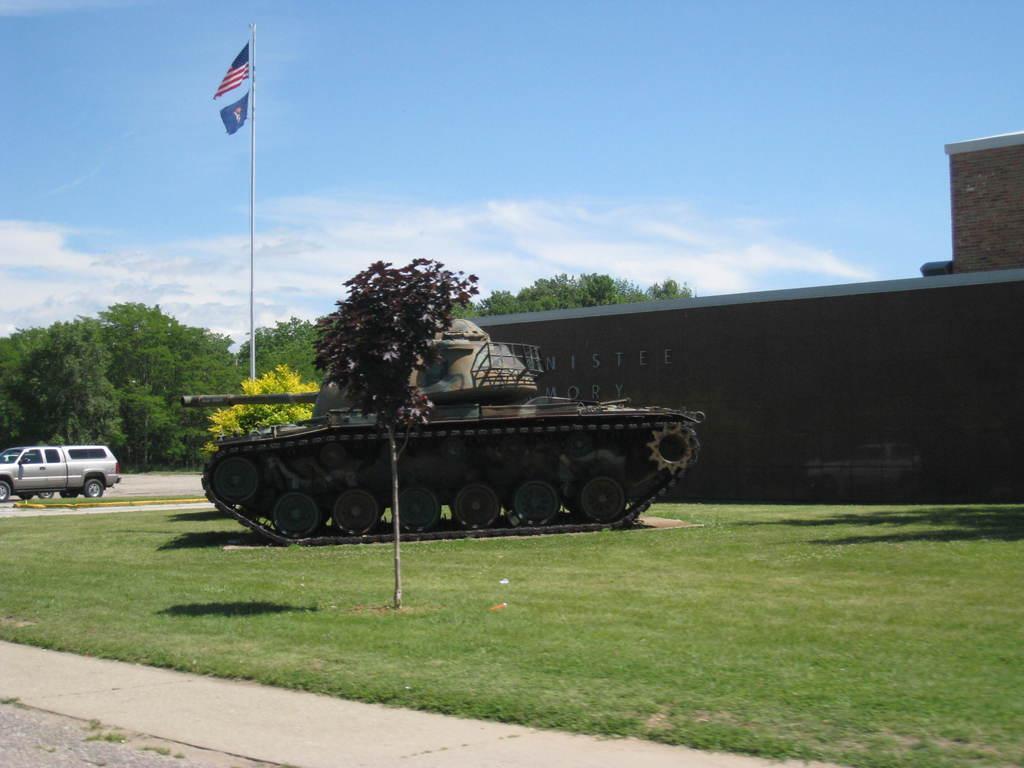Describe this image in one or two sentences. In the center of the image, we can see a military vehicle and in the background, there are trees, a building and we can see a flag and there are vehicles on the road and there is ground. At the top, there are clouds in the sky. 